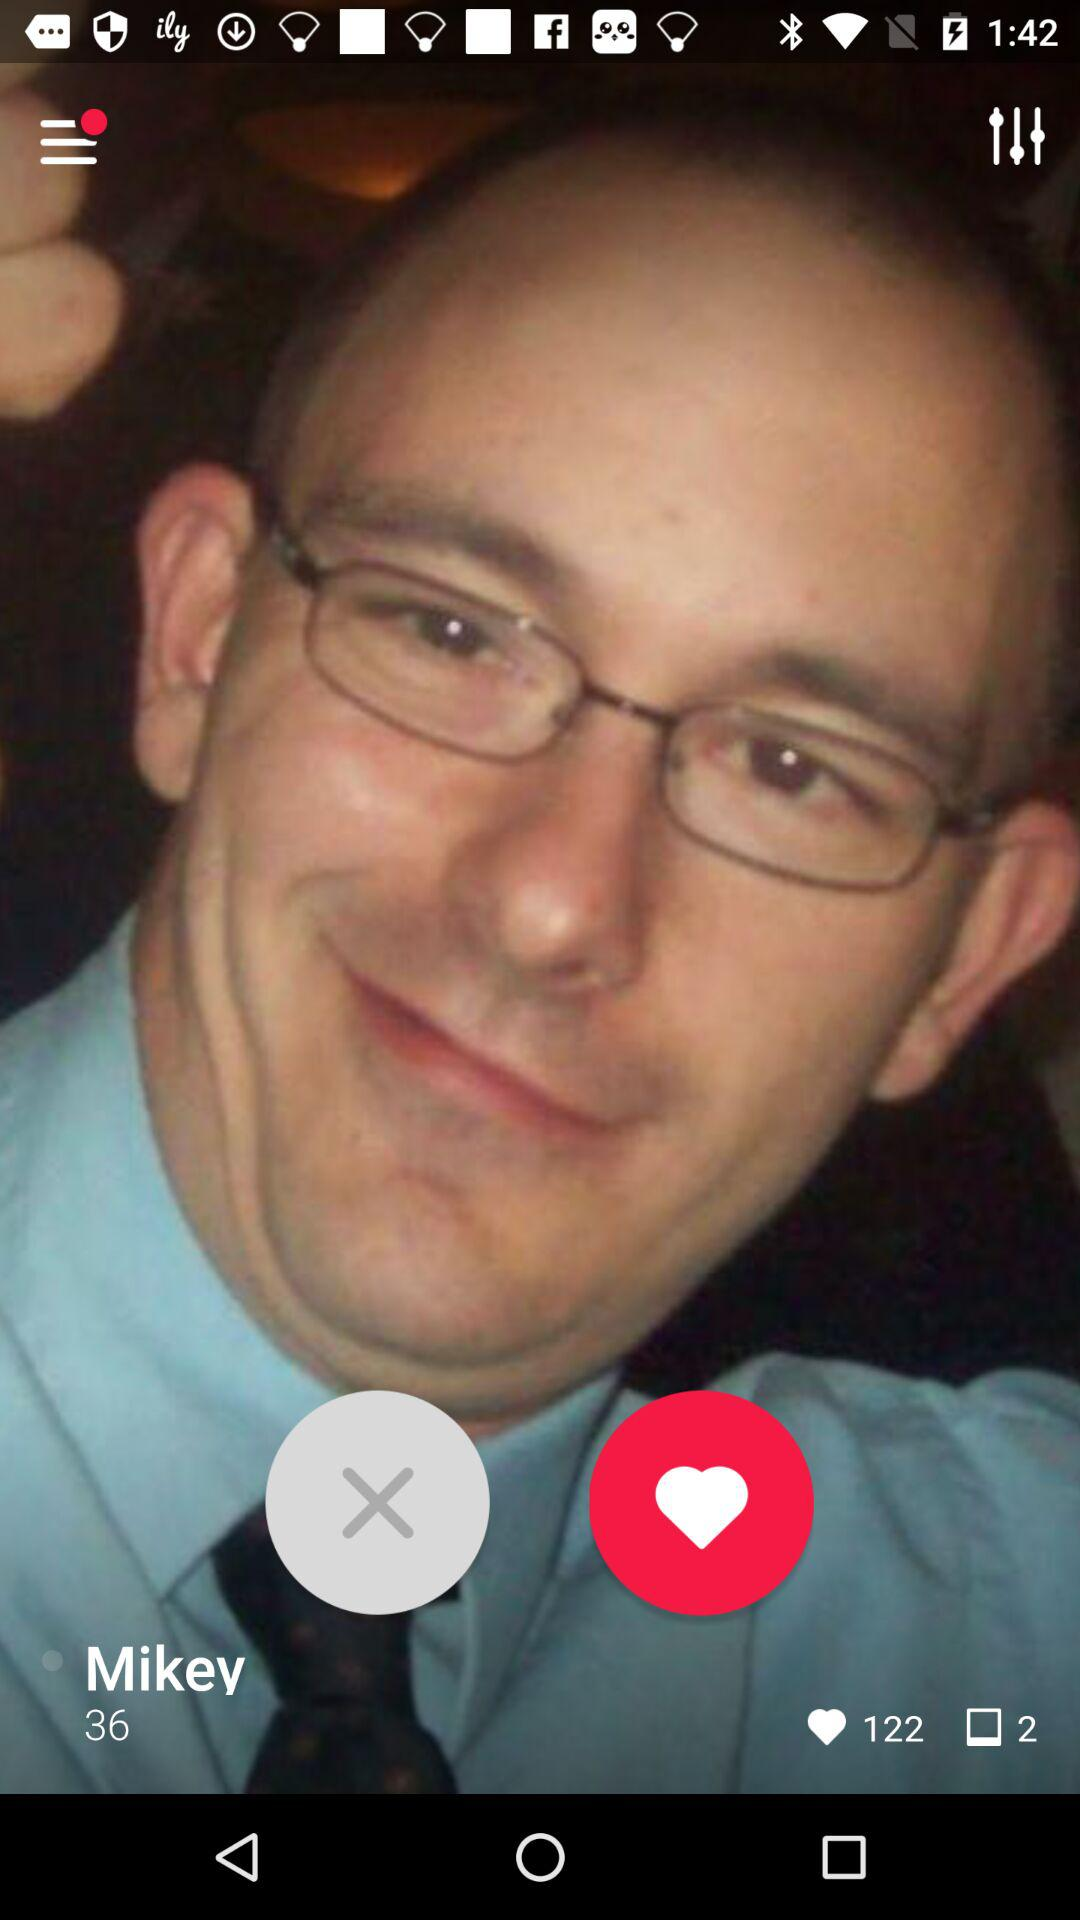What is the name of the person? The name of the person is Mikey. 